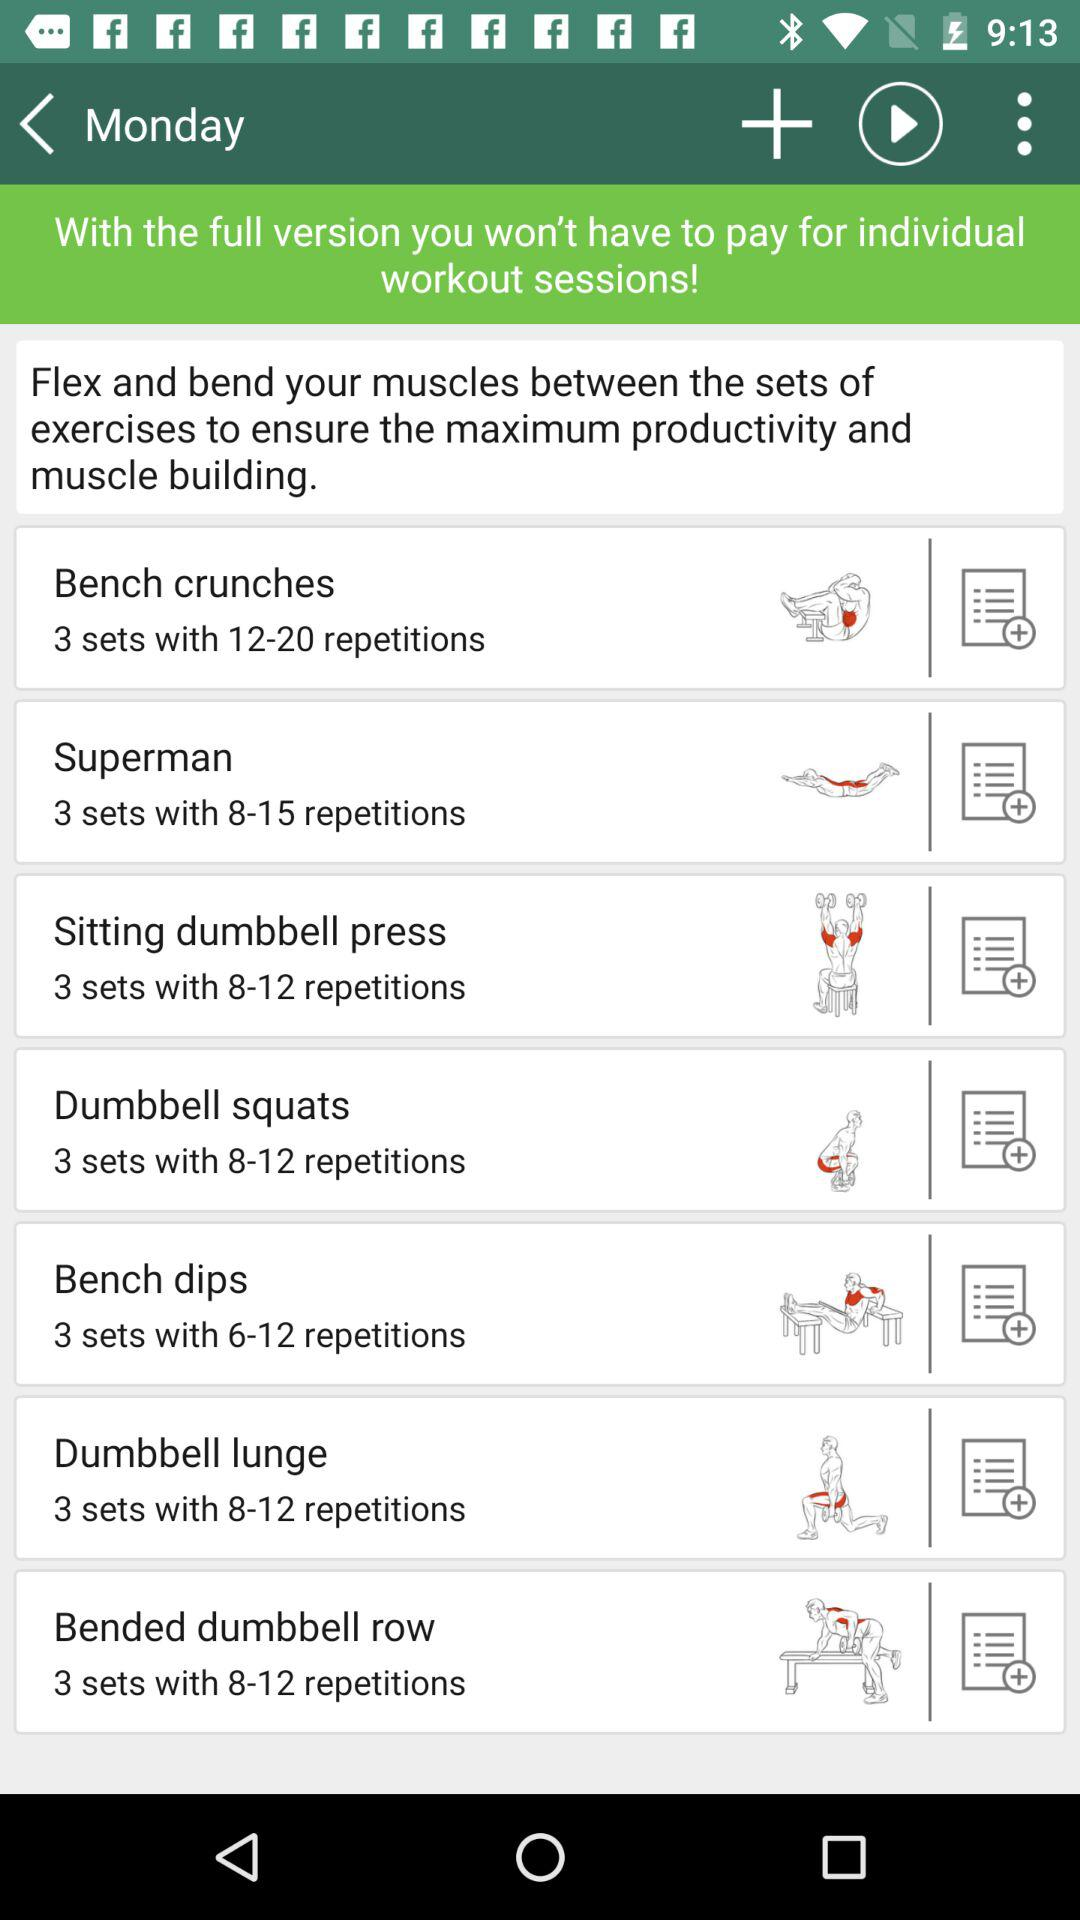What is the total number of repetitions of the Superman exercise? The total number of repetitions is 8–15. 